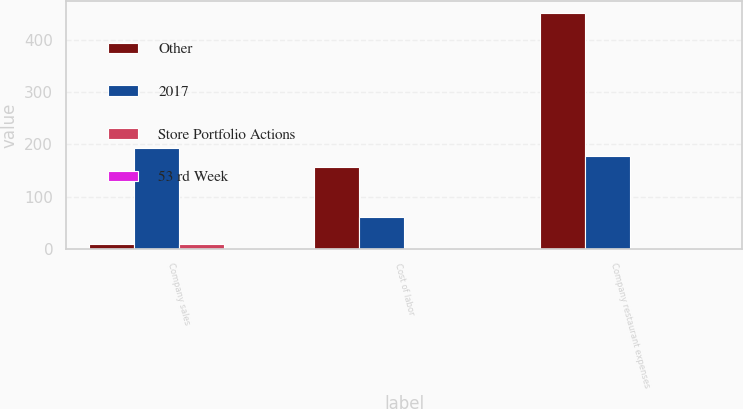Convert chart. <chart><loc_0><loc_0><loc_500><loc_500><stacked_bar_chart><ecel><fcel>Company sales<fcel>Cost of labor<fcel>Company restaurant expenses<nl><fcel>Other<fcel>9<fcel>156<fcel>452<nl><fcel>2017<fcel>193<fcel>61<fcel>178<nl><fcel>Store Portfolio Actions<fcel>9<fcel>1<fcel>2<nl><fcel>53 rd Week<fcel>1<fcel>1<fcel>1<nl></chart> 